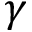<formula> <loc_0><loc_0><loc_500><loc_500>\gamma</formula> 